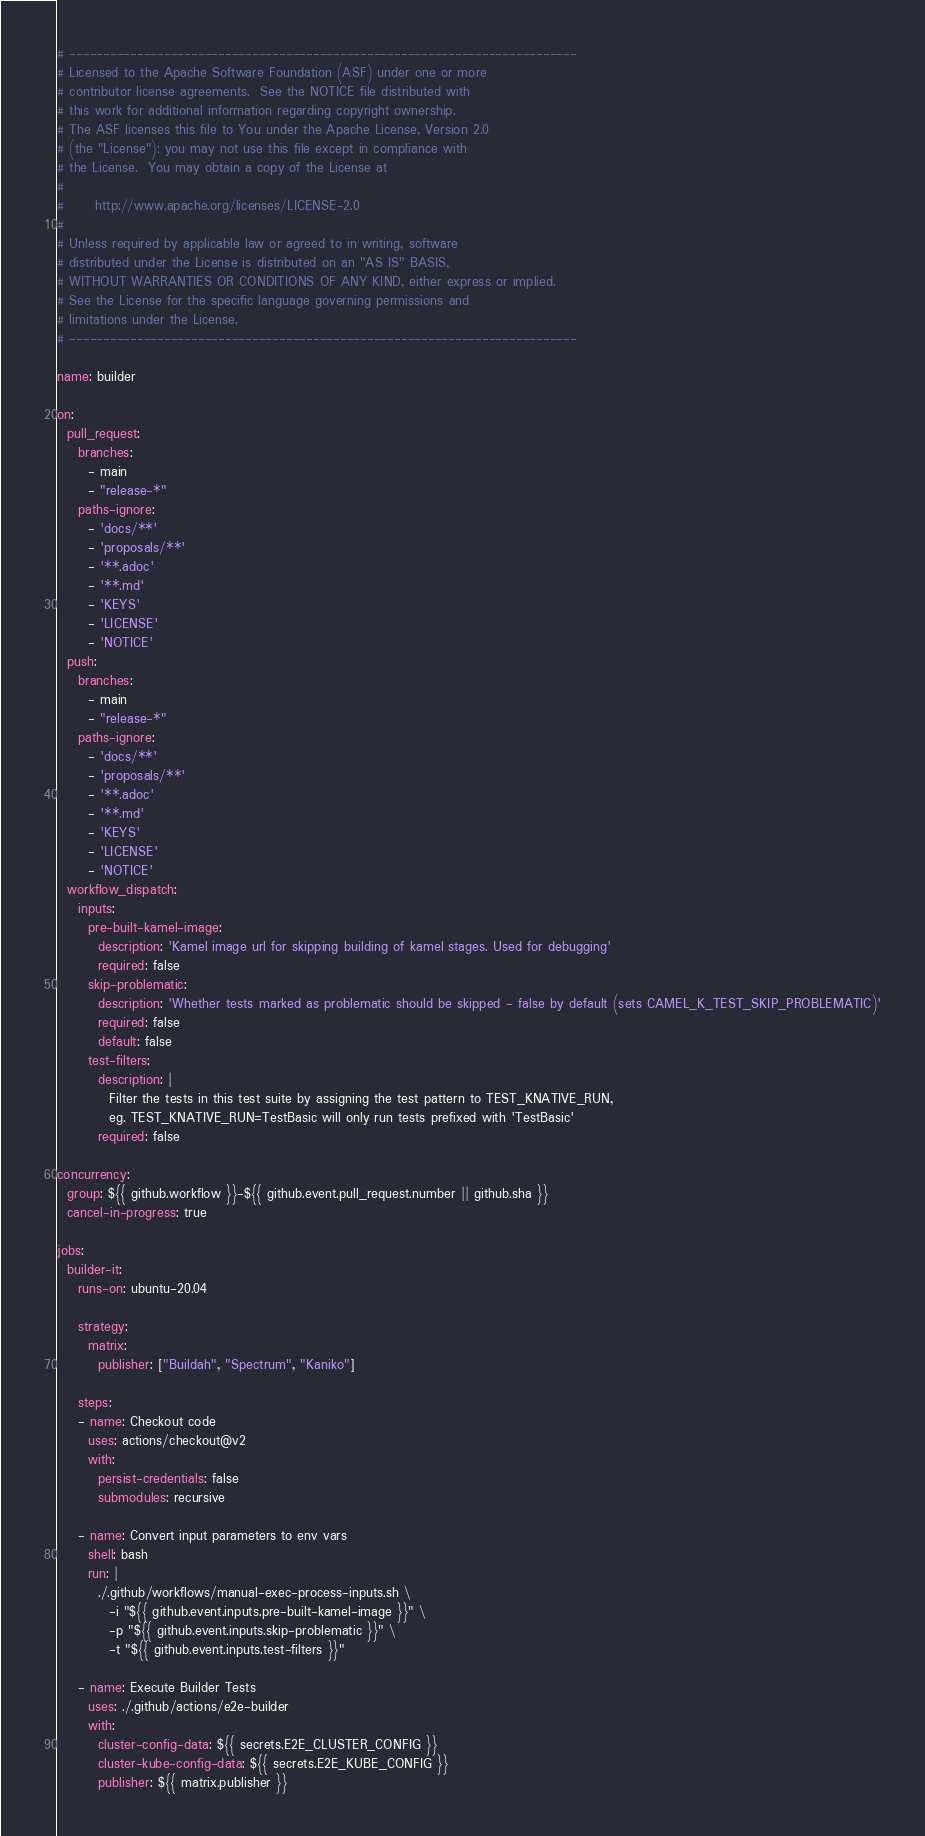Convert code to text. <code><loc_0><loc_0><loc_500><loc_500><_YAML_># ---------------------------------------------------------------------------
# Licensed to the Apache Software Foundation (ASF) under one or more
# contributor license agreements.  See the NOTICE file distributed with
# this work for additional information regarding copyright ownership.
# The ASF licenses this file to You under the Apache License, Version 2.0
# (the "License"); you may not use this file except in compliance with
# the License.  You may obtain a copy of the License at
#
#      http://www.apache.org/licenses/LICENSE-2.0
#
# Unless required by applicable law or agreed to in writing, software
# distributed under the License is distributed on an "AS IS" BASIS,
# WITHOUT WARRANTIES OR CONDITIONS OF ANY KIND, either express or implied.
# See the License for the specific language governing permissions and
# limitations under the License.
# ---------------------------------------------------------------------------

name: builder

on:
  pull_request:
    branches:
      - main
      - "release-*"
    paths-ignore:
      - 'docs/**'
      - 'proposals/**'
      - '**.adoc'
      - '**.md'
      - 'KEYS'
      - 'LICENSE'
      - 'NOTICE'
  push:
    branches:
      - main
      - "release-*"
    paths-ignore:
      - 'docs/**'
      - 'proposals/**'
      - '**.adoc'
      - '**.md'
      - 'KEYS'
      - 'LICENSE'
      - 'NOTICE'
  workflow_dispatch:
    inputs:
      pre-built-kamel-image:
        description: 'Kamel image url for skipping building of kamel stages. Used for debugging'
        required: false
      skip-problematic:
        description: 'Whether tests marked as problematic should be skipped - false by default (sets CAMEL_K_TEST_SKIP_PROBLEMATIC)'
        required: false
        default: false
      test-filters:
        description: |
          Filter the tests in this test suite by assigning the test pattern to TEST_KNATIVE_RUN,
          eg. TEST_KNATIVE_RUN=TestBasic will only run tests prefixed with 'TestBasic'
        required: false

concurrency:
  group: ${{ github.workflow }}-${{ github.event.pull_request.number || github.sha }}
  cancel-in-progress: true

jobs:
  builder-it:
    runs-on: ubuntu-20.04

    strategy:
      matrix:
        publisher: ["Buildah", "Spectrum", "Kaniko"]

    steps:
    - name: Checkout code
      uses: actions/checkout@v2
      with:
        persist-credentials: false
        submodules: recursive

    - name: Convert input parameters to env vars
      shell: bash
      run: |
        ./.github/workflows/manual-exec-process-inputs.sh \
          -i "${{ github.event.inputs.pre-built-kamel-image }}" \
          -p "${{ github.event.inputs.skip-problematic }}" \
          -t "${{ github.event.inputs.test-filters }}"

    - name: Execute Builder Tests
      uses: ./.github/actions/e2e-builder
      with:
        cluster-config-data: ${{ secrets.E2E_CLUSTER_CONFIG }}
        cluster-kube-config-data: ${{ secrets.E2E_KUBE_CONFIG }}
        publisher: ${{ matrix.publisher }}
</code> 